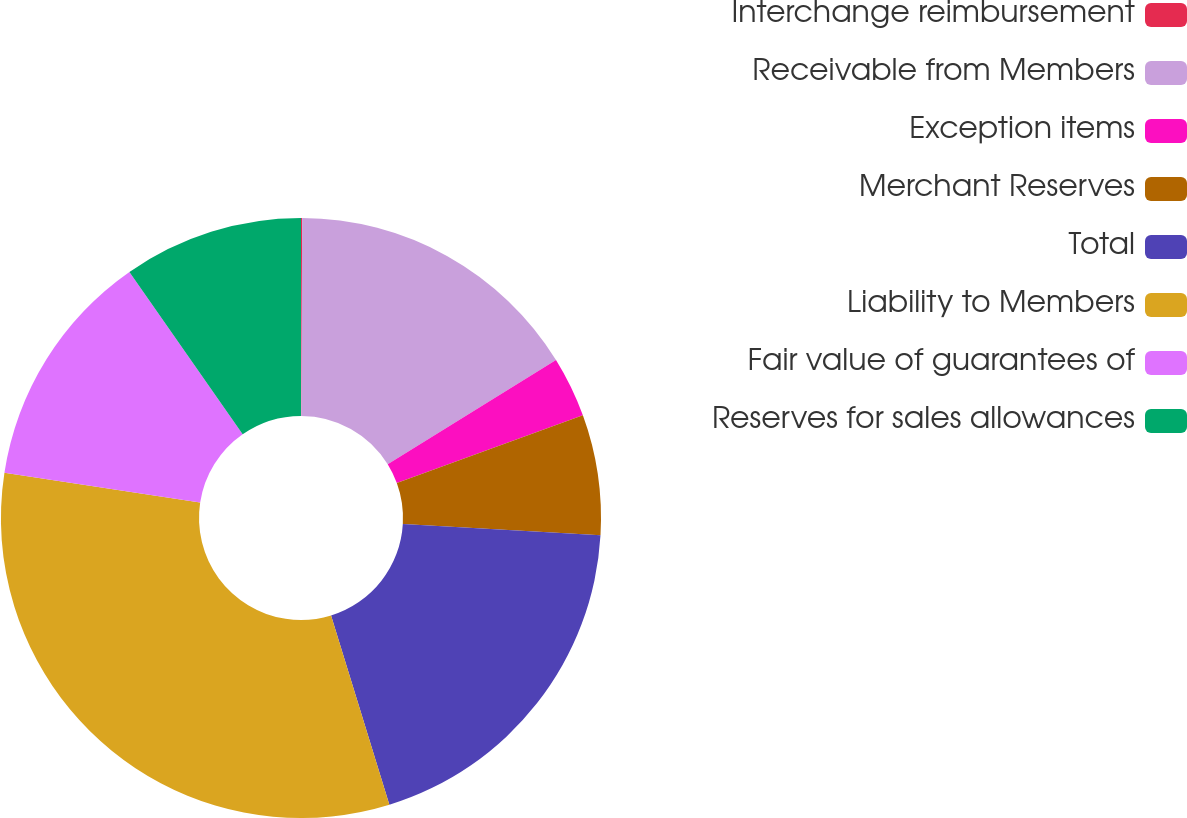<chart> <loc_0><loc_0><loc_500><loc_500><pie_chart><fcel>Interchange reimbursement<fcel>Receivable from Members<fcel>Exception items<fcel>Merchant Reserves<fcel>Total<fcel>Liability to Members<fcel>Fair value of guarantees of<fcel>Reserves for sales allowances<nl><fcel>0.06%<fcel>16.11%<fcel>3.27%<fcel>6.48%<fcel>19.32%<fcel>32.17%<fcel>12.9%<fcel>9.69%<nl></chart> 